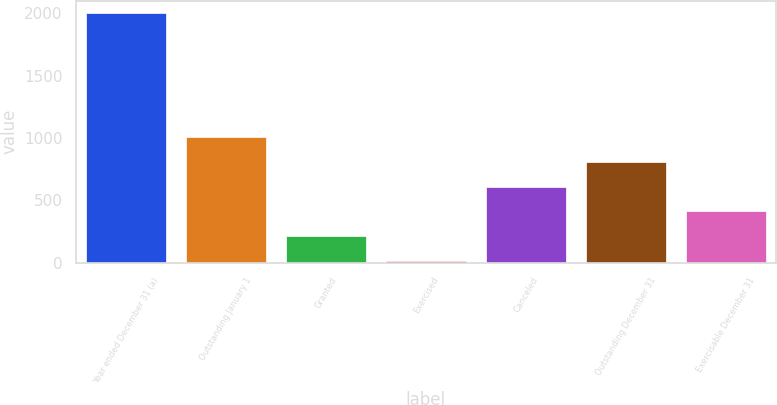<chart> <loc_0><loc_0><loc_500><loc_500><bar_chart><fcel>Year ended December 31 (a)<fcel>Outstanding January 1<fcel>Granted<fcel>Exercised<fcel>Canceled<fcel>Outstanding December 31<fcel>Exercisable December 31<nl><fcel>2003<fcel>1008.32<fcel>212.6<fcel>13.67<fcel>610.46<fcel>809.39<fcel>411.53<nl></chart> 